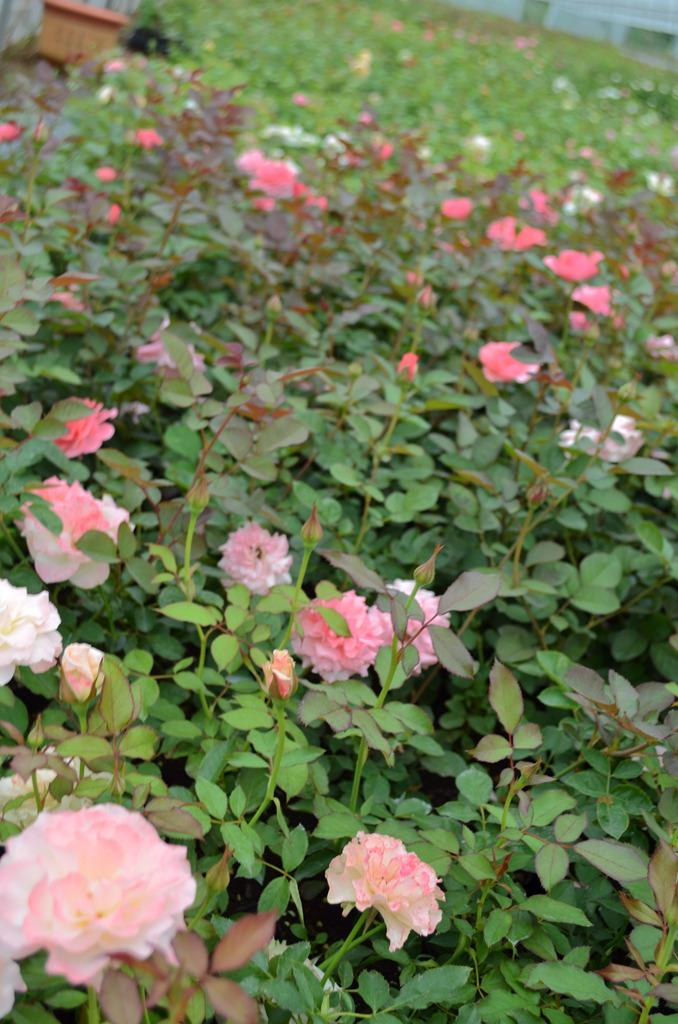What type of garden is depicted in the image? The image contains a flower garden. What color of roses can be seen in the garden? There are pink roses and white roses in the garden. How many spiders are crawling on the lumber in the image? There is no lumber or spiders present in the image; it features a flower garden with pink and white roses. 